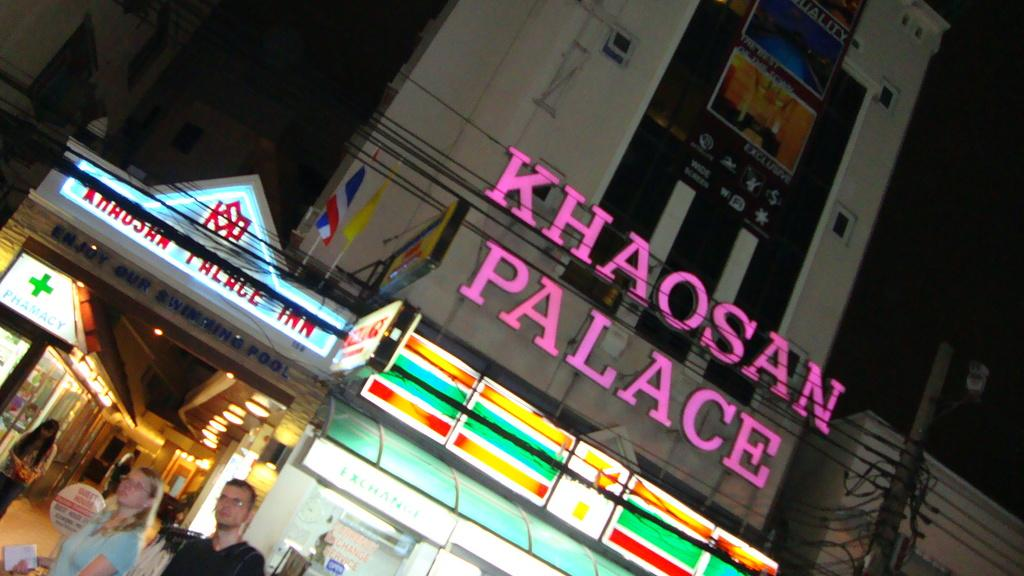Who or what can be seen on the right side of the image? There are people on the right side of the image. What object is present in the image that might be used for displaying information or messages? There is a board in the image. What type of structures can be seen in the image? There are buildings visible in the image. What feature can be observed on top of the buildings? There are lights on top of the buildings. Can you tell me how many lizards are sitting on the board in the image? There are no lizards present in the image; the board is the only object mentioned in the facts. 